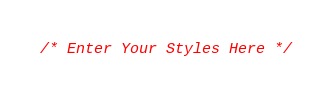Convert code to text. <code><loc_0><loc_0><loc_500><loc_500><_CSS_>/* Enter Your Styles Here */</code> 